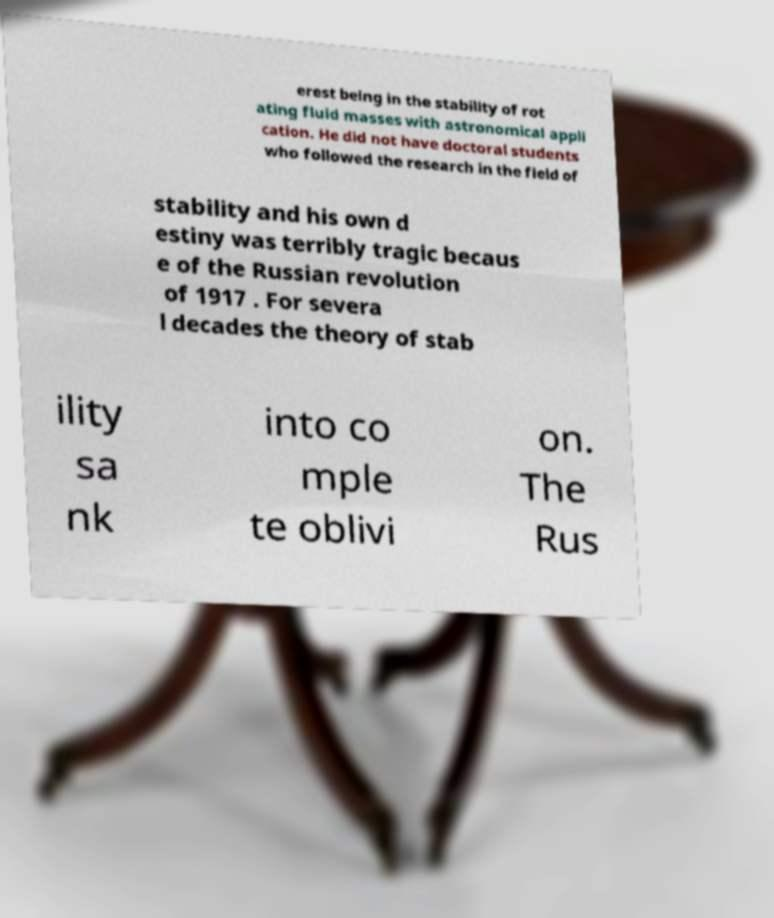Can you accurately transcribe the text from the provided image for me? erest being in the stability of rot ating fluid masses with astronomical appli cation. He did not have doctoral students who followed the research in the field of stability and his own d estiny was terribly tragic becaus e of the Russian revolution of 1917 . For severa l decades the theory of stab ility sa nk into co mple te oblivi on. The Rus 